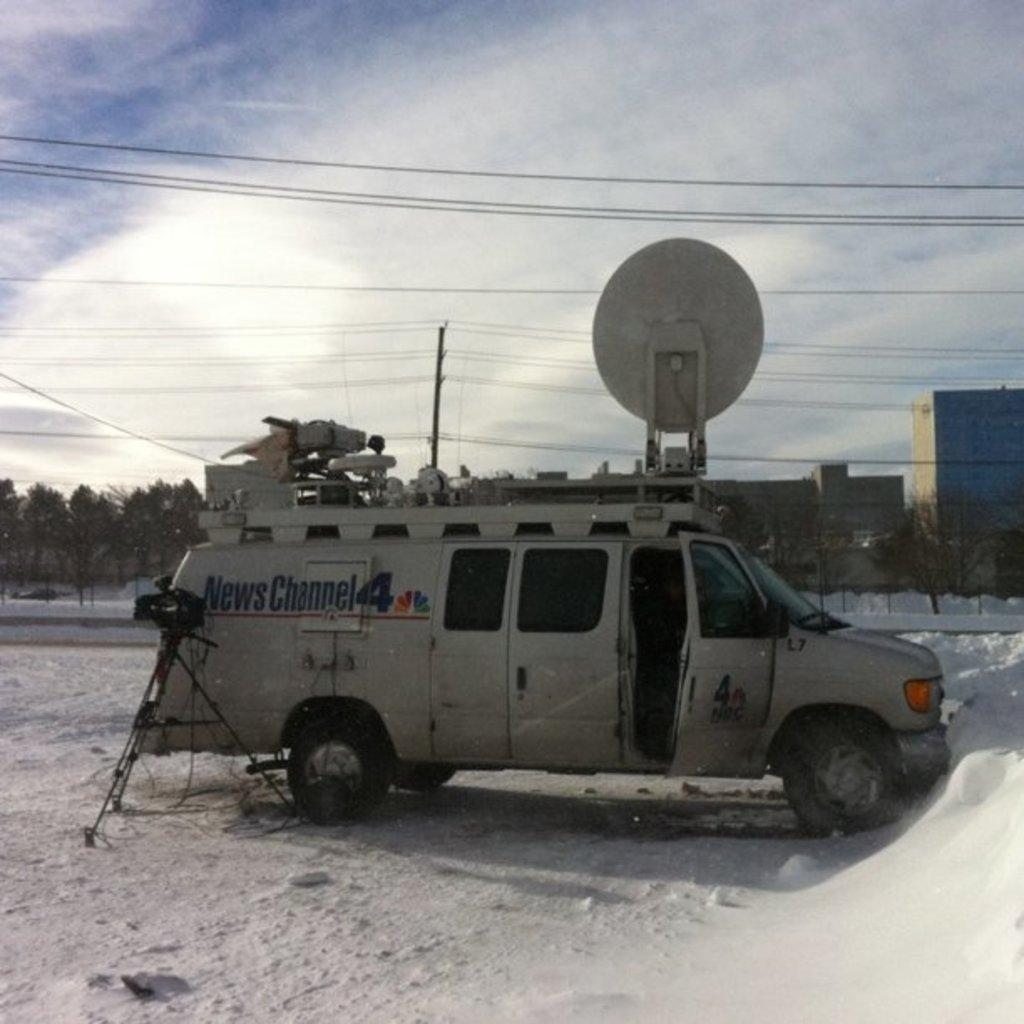What can be seen in the sky in the image? The sky is visible in the image, but no specific details about the sky are mentioned in the facts. What is attached to the wires in the image? The facts do not specify what is attached to the wires. What is the pole used for in the image? The purpose of the pole in the image is not mentioned in the facts. What type of vegetation is present in the image? There are trees in the image. What type of structures are visible in the image? There are buildings in the image. What mode of transportation is in the image? There is a vehicle in the image. What device is used for capturing images in the image? There is a camera on a stand in the image. What color is the burst of orange in the image? There is no burst of orange present in the image. Where is the middle of the image located? The concept of a "middle" of the image is abstract and cannot be definitively answered based on the provided facts. 